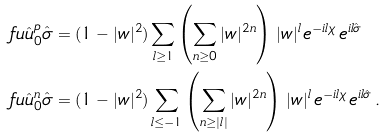<formula> <loc_0><loc_0><loc_500><loc_500>\ f u { \hat { u } _ { 0 } ^ { p } } { \hat { \sigma } } & = ( 1 - | w | ^ { 2 } ) \sum _ { l \geq 1 } \left ( \sum _ { n \geq 0 } | w | ^ { 2 n } \right ) \, | w | ^ { l } \, e ^ { - i l \chi } \, e ^ { i l \hat { \sigma } } \\ \ f u { \hat { u } _ { 0 } ^ { n } } { \hat { \sigma } } & = ( 1 - | w | ^ { 2 } ) \sum _ { l \leq - 1 } \left ( \sum _ { n \geq | l | } | w | ^ { 2 n } \right ) \, | w | ^ { l } \, e ^ { - i l \chi } \, e ^ { i l \hat { \sigma } } \, .</formula> 